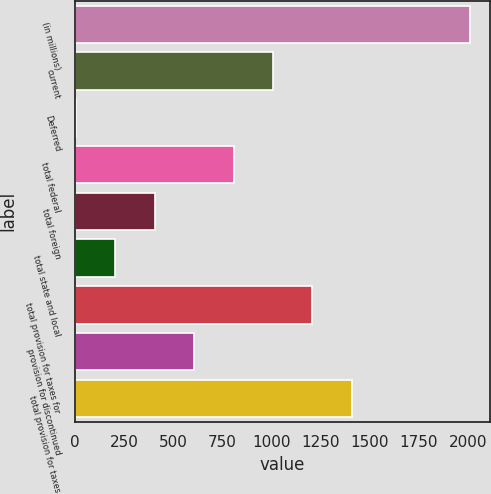<chart> <loc_0><loc_0><loc_500><loc_500><bar_chart><fcel>(in millions)<fcel>current<fcel>Deferred<fcel>total federal<fcel>total foreign<fcel>total state and local<fcel>total provision for taxes for<fcel>provision for discontinued<fcel>total provision for taxes<nl><fcel>2011<fcel>1008.5<fcel>6<fcel>808<fcel>407<fcel>206.5<fcel>1209<fcel>607.5<fcel>1409.5<nl></chart> 